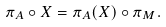Convert formula to latex. <formula><loc_0><loc_0><loc_500><loc_500>\pi _ { A } \circ X = \pi _ { A } ( X ) \circ \pi _ { M } .</formula> 